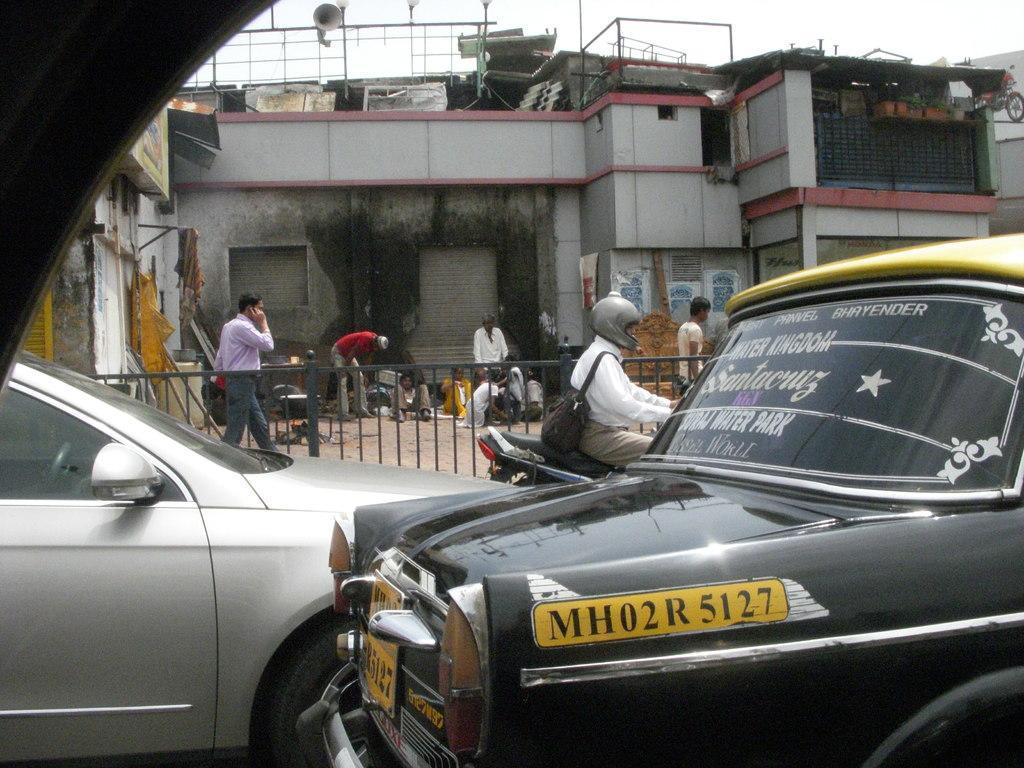In one or two sentences, can you explain what this image depicts? At the bottom of the image there are cars and we can see a man sitting on the bike. In the background there is a fence and we can see people. There are buildings. At the top there is sky. 